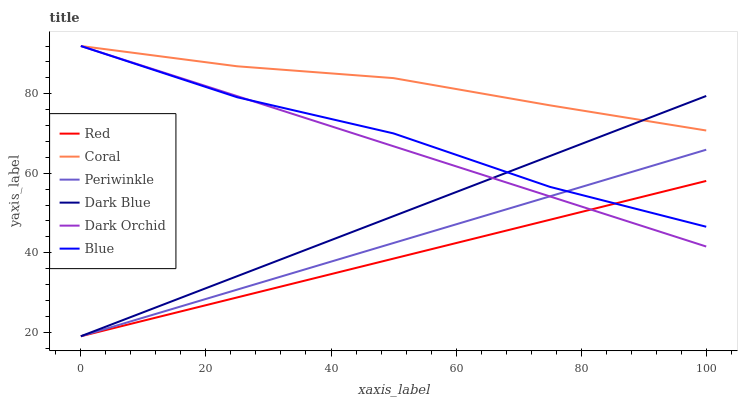Does Red have the minimum area under the curve?
Answer yes or no. Yes. Does Coral have the maximum area under the curve?
Answer yes or no. Yes. Does Dark Orchid have the minimum area under the curve?
Answer yes or no. No. Does Dark Orchid have the maximum area under the curve?
Answer yes or no. No. Is Periwinkle the smoothest?
Answer yes or no. Yes. Is Blue the roughest?
Answer yes or no. Yes. Is Coral the smoothest?
Answer yes or no. No. Is Coral the roughest?
Answer yes or no. No. Does Dark Blue have the lowest value?
Answer yes or no. Yes. Does Dark Orchid have the lowest value?
Answer yes or no. No. Does Dark Orchid have the highest value?
Answer yes or no. Yes. Does Dark Blue have the highest value?
Answer yes or no. No. Is Red less than Coral?
Answer yes or no. Yes. Is Coral greater than Periwinkle?
Answer yes or no. Yes. Does Dark Blue intersect Red?
Answer yes or no. Yes. Is Dark Blue less than Red?
Answer yes or no. No. Is Dark Blue greater than Red?
Answer yes or no. No. Does Red intersect Coral?
Answer yes or no. No. 